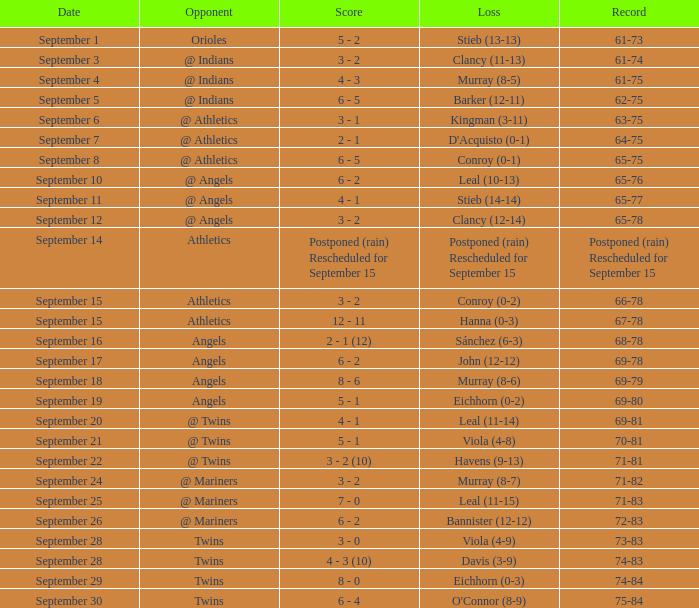Name the score for september 11 4 - 1. 